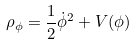<formula> <loc_0><loc_0><loc_500><loc_500>\rho _ { \phi } = \frac { 1 } { 2 } \dot { \phi } ^ { 2 } + V ( \phi )</formula> 